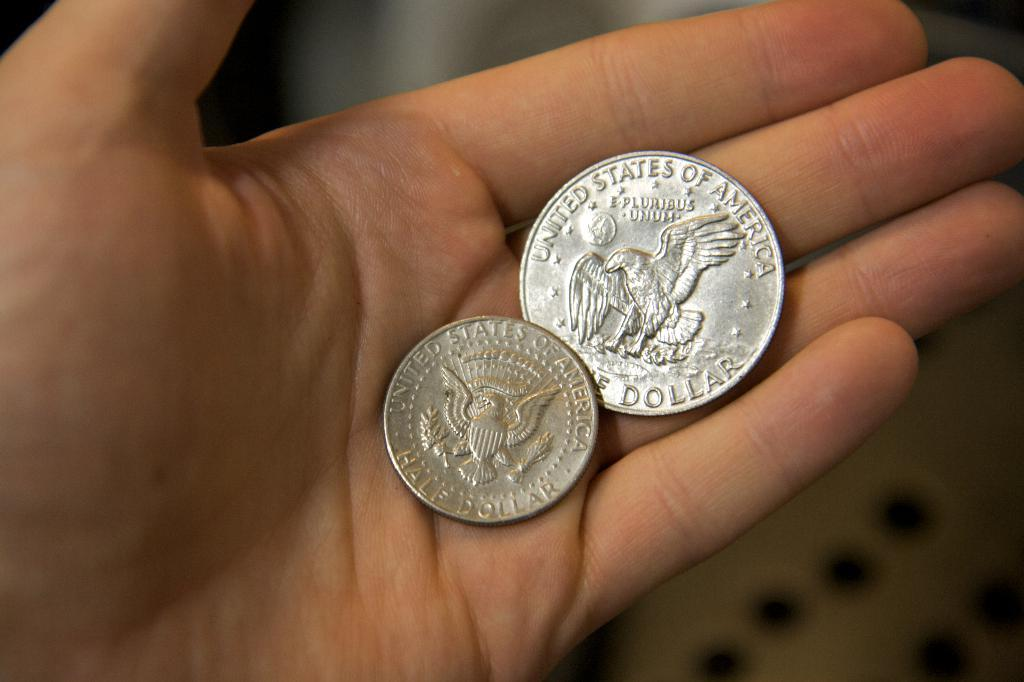<image>
Render a clear and concise summary of the photo. A person is holding a quarter with an eagle on the back that says E. Pluribus Unum. 